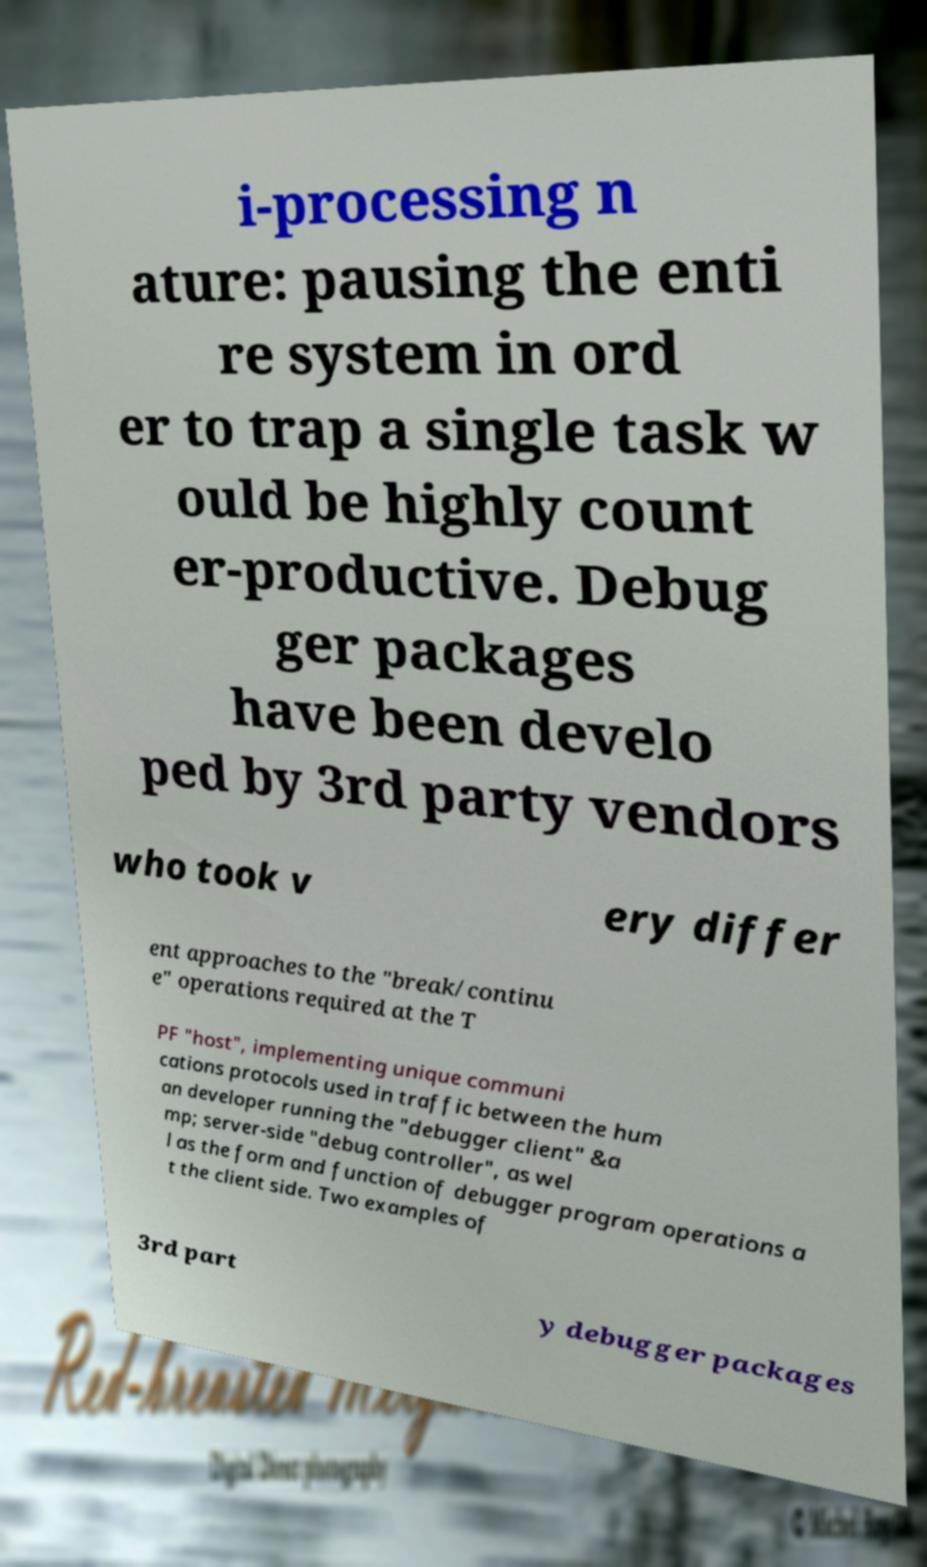There's text embedded in this image that I need extracted. Can you transcribe it verbatim? i-processing n ature: pausing the enti re system in ord er to trap a single task w ould be highly count er-productive. Debug ger packages have been develo ped by 3rd party vendors who took v ery differ ent approaches to the "break/continu e" operations required at the T PF "host", implementing unique communi cations protocols used in traffic between the hum an developer running the "debugger client" &a mp; server-side "debug controller", as wel l as the form and function of debugger program operations a t the client side. Two examples of 3rd part y debugger packages 